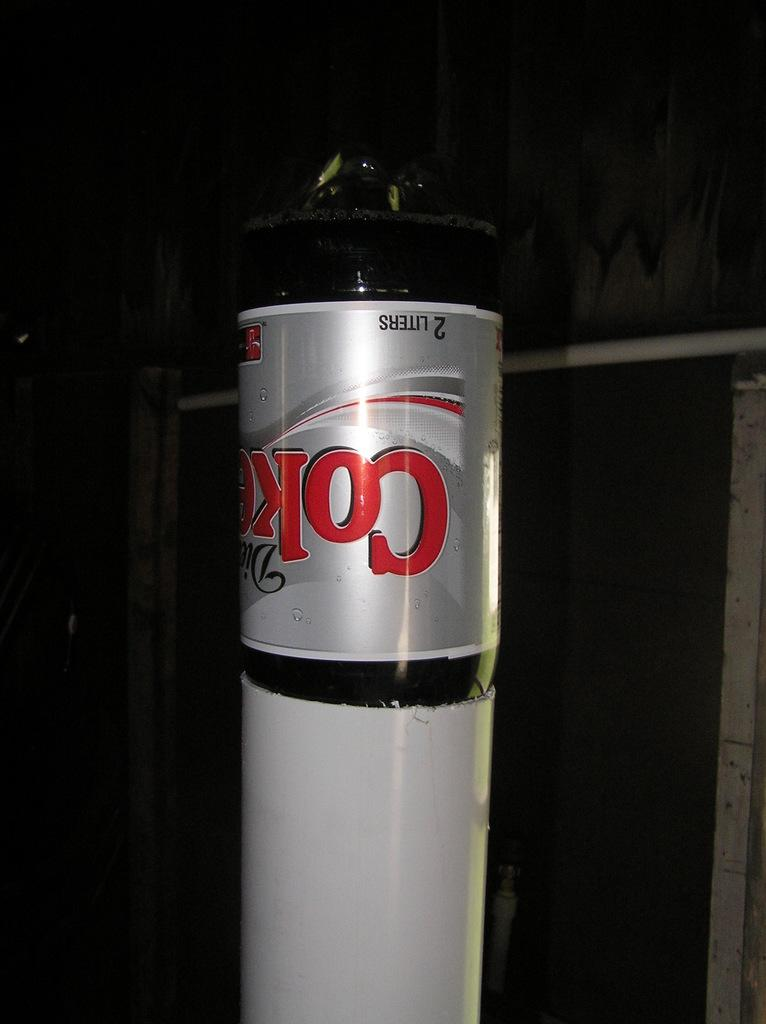<image>
Describe the image concisely. A 2 liter bottle says Coke and is upside down in a pipe. 